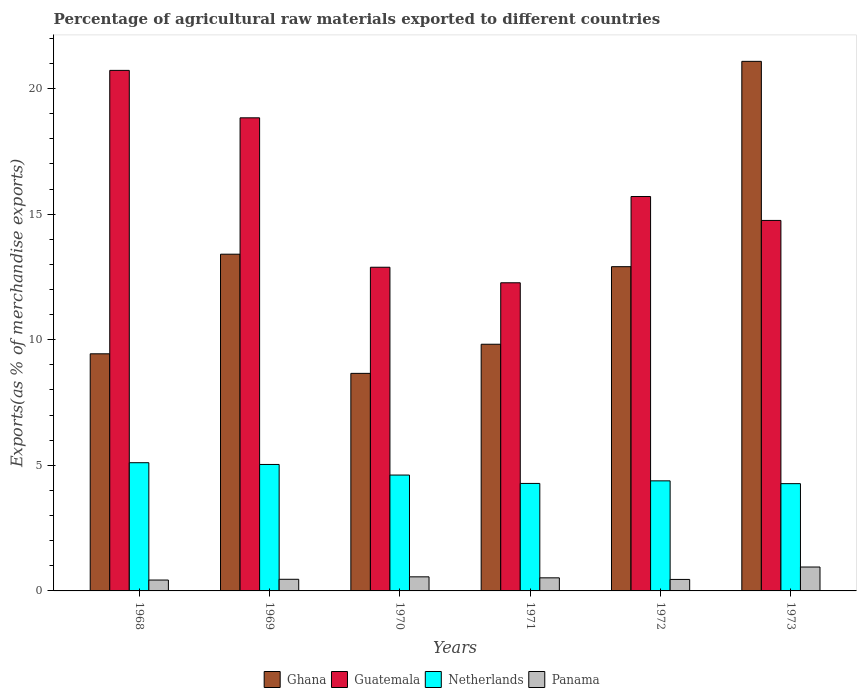How many different coloured bars are there?
Ensure brevity in your answer.  4. How many groups of bars are there?
Your answer should be compact. 6. Are the number of bars per tick equal to the number of legend labels?
Your answer should be very brief. Yes. Are the number of bars on each tick of the X-axis equal?
Provide a short and direct response. Yes. How many bars are there on the 2nd tick from the right?
Provide a succinct answer. 4. What is the label of the 5th group of bars from the left?
Ensure brevity in your answer.  1972. What is the percentage of exports to different countries in Guatemala in 1972?
Offer a very short reply. 15.7. Across all years, what is the maximum percentage of exports to different countries in Netherlands?
Your answer should be very brief. 5.1. Across all years, what is the minimum percentage of exports to different countries in Ghana?
Keep it short and to the point. 8.66. In which year was the percentage of exports to different countries in Guatemala maximum?
Offer a terse response. 1968. What is the total percentage of exports to different countries in Netherlands in the graph?
Offer a very short reply. 27.68. What is the difference between the percentage of exports to different countries in Panama in 1970 and that in 1973?
Ensure brevity in your answer.  -0.39. What is the difference between the percentage of exports to different countries in Panama in 1973 and the percentage of exports to different countries in Netherlands in 1971?
Give a very brief answer. -3.33. What is the average percentage of exports to different countries in Panama per year?
Your answer should be compact. 0.56. In the year 1973, what is the difference between the percentage of exports to different countries in Netherlands and percentage of exports to different countries in Guatemala?
Offer a very short reply. -10.48. In how many years, is the percentage of exports to different countries in Ghana greater than 3 %?
Give a very brief answer. 6. What is the ratio of the percentage of exports to different countries in Ghana in 1970 to that in 1971?
Keep it short and to the point. 0.88. Is the difference between the percentage of exports to different countries in Netherlands in 1968 and 1972 greater than the difference between the percentage of exports to different countries in Guatemala in 1968 and 1972?
Give a very brief answer. No. What is the difference between the highest and the second highest percentage of exports to different countries in Netherlands?
Keep it short and to the point. 0.07. What is the difference between the highest and the lowest percentage of exports to different countries in Panama?
Provide a short and direct response. 0.52. In how many years, is the percentage of exports to different countries in Netherlands greater than the average percentage of exports to different countries in Netherlands taken over all years?
Ensure brevity in your answer.  2. Is it the case that in every year, the sum of the percentage of exports to different countries in Panama and percentage of exports to different countries in Guatemala is greater than the sum of percentage of exports to different countries in Netherlands and percentage of exports to different countries in Ghana?
Offer a terse response. No. What does the 2nd bar from the left in 1971 represents?
Offer a very short reply. Guatemala. What does the 4th bar from the right in 1969 represents?
Offer a terse response. Ghana. How many bars are there?
Provide a short and direct response. 24. Are the values on the major ticks of Y-axis written in scientific E-notation?
Give a very brief answer. No. Does the graph contain any zero values?
Your response must be concise. No. Does the graph contain grids?
Ensure brevity in your answer.  No. Where does the legend appear in the graph?
Provide a short and direct response. Bottom center. How many legend labels are there?
Your response must be concise. 4. How are the legend labels stacked?
Offer a very short reply. Horizontal. What is the title of the graph?
Keep it short and to the point. Percentage of agricultural raw materials exported to different countries. What is the label or title of the Y-axis?
Offer a very short reply. Exports(as % of merchandise exports). What is the Exports(as % of merchandise exports) of Ghana in 1968?
Keep it short and to the point. 9.44. What is the Exports(as % of merchandise exports) in Guatemala in 1968?
Give a very brief answer. 20.72. What is the Exports(as % of merchandise exports) of Netherlands in 1968?
Provide a short and direct response. 5.1. What is the Exports(as % of merchandise exports) of Panama in 1968?
Make the answer very short. 0.43. What is the Exports(as % of merchandise exports) in Ghana in 1969?
Offer a terse response. 13.41. What is the Exports(as % of merchandise exports) in Guatemala in 1969?
Make the answer very short. 18.83. What is the Exports(as % of merchandise exports) of Netherlands in 1969?
Provide a short and direct response. 5.03. What is the Exports(as % of merchandise exports) of Panama in 1969?
Keep it short and to the point. 0.46. What is the Exports(as % of merchandise exports) in Ghana in 1970?
Offer a very short reply. 8.66. What is the Exports(as % of merchandise exports) of Guatemala in 1970?
Offer a terse response. 12.89. What is the Exports(as % of merchandise exports) of Netherlands in 1970?
Make the answer very short. 4.61. What is the Exports(as % of merchandise exports) in Panama in 1970?
Your response must be concise. 0.56. What is the Exports(as % of merchandise exports) of Ghana in 1971?
Your answer should be compact. 9.82. What is the Exports(as % of merchandise exports) of Guatemala in 1971?
Your answer should be compact. 12.27. What is the Exports(as % of merchandise exports) in Netherlands in 1971?
Your answer should be very brief. 4.28. What is the Exports(as % of merchandise exports) of Panama in 1971?
Your answer should be compact. 0.52. What is the Exports(as % of merchandise exports) in Ghana in 1972?
Ensure brevity in your answer.  12.91. What is the Exports(as % of merchandise exports) in Guatemala in 1972?
Your answer should be very brief. 15.7. What is the Exports(as % of merchandise exports) of Netherlands in 1972?
Give a very brief answer. 4.38. What is the Exports(as % of merchandise exports) of Panama in 1972?
Offer a very short reply. 0.46. What is the Exports(as % of merchandise exports) of Ghana in 1973?
Your answer should be very brief. 21.08. What is the Exports(as % of merchandise exports) in Guatemala in 1973?
Offer a terse response. 14.75. What is the Exports(as % of merchandise exports) of Netherlands in 1973?
Offer a very short reply. 4.27. What is the Exports(as % of merchandise exports) in Panama in 1973?
Your answer should be very brief. 0.95. Across all years, what is the maximum Exports(as % of merchandise exports) in Ghana?
Offer a terse response. 21.08. Across all years, what is the maximum Exports(as % of merchandise exports) in Guatemala?
Ensure brevity in your answer.  20.72. Across all years, what is the maximum Exports(as % of merchandise exports) of Netherlands?
Your answer should be very brief. 5.1. Across all years, what is the maximum Exports(as % of merchandise exports) of Panama?
Give a very brief answer. 0.95. Across all years, what is the minimum Exports(as % of merchandise exports) of Ghana?
Your answer should be very brief. 8.66. Across all years, what is the minimum Exports(as % of merchandise exports) in Guatemala?
Provide a short and direct response. 12.27. Across all years, what is the minimum Exports(as % of merchandise exports) of Netherlands?
Give a very brief answer. 4.27. Across all years, what is the minimum Exports(as % of merchandise exports) in Panama?
Your response must be concise. 0.43. What is the total Exports(as % of merchandise exports) in Ghana in the graph?
Make the answer very short. 75.32. What is the total Exports(as % of merchandise exports) in Guatemala in the graph?
Offer a very short reply. 95.16. What is the total Exports(as % of merchandise exports) in Netherlands in the graph?
Give a very brief answer. 27.68. What is the total Exports(as % of merchandise exports) of Panama in the graph?
Provide a short and direct response. 3.39. What is the difference between the Exports(as % of merchandise exports) of Ghana in 1968 and that in 1969?
Offer a terse response. -3.97. What is the difference between the Exports(as % of merchandise exports) in Guatemala in 1968 and that in 1969?
Keep it short and to the point. 1.89. What is the difference between the Exports(as % of merchandise exports) in Netherlands in 1968 and that in 1969?
Your answer should be very brief. 0.07. What is the difference between the Exports(as % of merchandise exports) of Panama in 1968 and that in 1969?
Offer a terse response. -0.03. What is the difference between the Exports(as % of merchandise exports) of Ghana in 1968 and that in 1970?
Offer a terse response. 0.78. What is the difference between the Exports(as % of merchandise exports) of Guatemala in 1968 and that in 1970?
Offer a very short reply. 7.84. What is the difference between the Exports(as % of merchandise exports) of Netherlands in 1968 and that in 1970?
Your answer should be very brief. 0.49. What is the difference between the Exports(as % of merchandise exports) of Panama in 1968 and that in 1970?
Make the answer very short. -0.13. What is the difference between the Exports(as % of merchandise exports) of Ghana in 1968 and that in 1971?
Offer a very short reply. -0.38. What is the difference between the Exports(as % of merchandise exports) in Guatemala in 1968 and that in 1971?
Give a very brief answer. 8.46. What is the difference between the Exports(as % of merchandise exports) in Netherlands in 1968 and that in 1971?
Ensure brevity in your answer.  0.82. What is the difference between the Exports(as % of merchandise exports) in Panama in 1968 and that in 1971?
Make the answer very short. -0.09. What is the difference between the Exports(as % of merchandise exports) of Ghana in 1968 and that in 1972?
Your response must be concise. -3.47. What is the difference between the Exports(as % of merchandise exports) in Guatemala in 1968 and that in 1972?
Provide a short and direct response. 5.02. What is the difference between the Exports(as % of merchandise exports) of Netherlands in 1968 and that in 1972?
Your answer should be very brief. 0.72. What is the difference between the Exports(as % of merchandise exports) of Panama in 1968 and that in 1972?
Offer a terse response. -0.02. What is the difference between the Exports(as % of merchandise exports) of Ghana in 1968 and that in 1973?
Your response must be concise. -11.64. What is the difference between the Exports(as % of merchandise exports) in Guatemala in 1968 and that in 1973?
Make the answer very short. 5.97. What is the difference between the Exports(as % of merchandise exports) of Netherlands in 1968 and that in 1973?
Offer a very short reply. 0.83. What is the difference between the Exports(as % of merchandise exports) in Panama in 1968 and that in 1973?
Provide a succinct answer. -0.52. What is the difference between the Exports(as % of merchandise exports) in Ghana in 1969 and that in 1970?
Your answer should be compact. 4.74. What is the difference between the Exports(as % of merchandise exports) in Guatemala in 1969 and that in 1970?
Make the answer very short. 5.95. What is the difference between the Exports(as % of merchandise exports) in Netherlands in 1969 and that in 1970?
Your answer should be very brief. 0.42. What is the difference between the Exports(as % of merchandise exports) of Panama in 1969 and that in 1970?
Your answer should be very brief. -0.1. What is the difference between the Exports(as % of merchandise exports) of Ghana in 1969 and that in 1971?
Provide a succinct answer. 3.58. What is the difference between the Exports(as % of merchandise exports) in Guatemala in 1969 and that in 1971?
Your answer should be compact. 6.57. What is the difference between the Exports(as % of merchandise exports) in Netherlands in 1969 and that in 1971?
Offer a very short reply. 0.76. What is the difference between the Exports(as % of merchandise exports) of Panama in 1969 and that in 1971?
Your answer should be very brief. -0.06. What is the difference between the Exports(as % of merchandise exports) in Ghana in 1969 and that in 1972?
Offer a very short reply. 0.5. What is the difference between the Exports(as % of merchandise exports) in Guatemala in 1969 and that in 1972?
Offer a very short reply. 3.13. What is the difference between the Exports(as % of merchandise exports) of Netherlands in 1969 and that in 1972?
Provide a succinct answer. 0.65. What is the difference between the Exports(as % of merchandise exports) in Panama in 1969 and that in 1972?
Give a very brief answer. 0.01. What is the difference between the Exports(as % of merchandise exports) in Ghana in 1969 and that in 1973?
Offer a terse response. -7.68. What is the difference between the Exports(as % of merchandise exports) in Guatemala in 1969 and that in 1973?
Give a very brief answer. 4.08. What is the difference between the Exports(as % of merchandise exports) in Netherlands in 1969 and that in 1973?
Offer a terse response. 0.76. What is the difference between the Exports(as % of merchandise exports) in Panama in 1969 and that in 1973?
Your response must be concise. -0.49. What is the difference between the Exports(as % of merchandise exports) of Ghana in 1970 and that in 1971?
Your answer should be very brief. -1.16. What is the difference between the Exports(as % of merchandise exports) of Guatemala in 1970 and that in 1971?
Provide a succinct answer. 0.62. What is the difference between the Exports(as % of merchandise exports) in Netherlands in 1970 and that in 1971?
Ensure brevity in your answer.  0.33. What is the difference between the Exports(as % of merchandise exports) of Panama in 1970 and that in 1971?
Your answer should be very brief. 0.04. What is the difference between the Exports(as % of merchandise exports) in Ghana in 1970 and that in 1972?
Your answer should be compact. -4.25. What is the difference between the Exports(as % of merchandise exports) of Guatemala in 1970 and that in 1972?
Offer a terse response. -2.82. What is the difference between the Exports(as % of merchandise exports) of Netherlands in 1970 and that in 1972?
Offer a terse response. 0.23. What is the difference between the Exports(as % of merchandise exports) of Panama in 1970 and that in 1972?
Provide a short and direct response. 0.1. What is the difference between the Exports(as % of merchandise exports) in Ghana in 1970 and that in 1973?
Your answer should be compact. -12.42. What is the difference between the Exports(as % of merchandise exports) in Guatemala in 1970 and that in 1973?
Ensure brevity in your answer.  -1.86. What is the difference between the Exports(as % of merchandise exports) in Netherlands in 1970 and that in 1973?
Make the answer very short. 0.34. What is the difference between the Exports(as % of merchandise exports) in Panama in 1970 and that in 1973?
Offer a very short reply. -0.39. What is the difference between the Exports(as % of merchandise exports) in Ghana in 1971 and that in 1972?
Provide a succinct answer. -3.09. What is the difference between the Exports(as % of merchandise exports) in Guatemala in 1971 and that in 1972?
Keep it short and to the point. -3.43. What is the difference between the Exports(as % of merchandise exports) of Netherlands in 1971 and that in 1972?
Offer a terse response. -0.1. What is the difference between the Exports(as % of merchandise exports) of Panama in 1971 and that in 1972?
Your answer should be very brief. 0.06. What is the difference between the Exports(as % of merchandise exports) in Ghana in 1971 and that in 1973?
Your answer should be very brief. -11.26. What is the difference between the Exports(as % of merchandise exports) in Guatemala in 1971 and that in 1973?
Your answer should be compact. -2.48. What is the difference between the Exports(as % of merchandise exports) of Netherlands in 1971 and that in 1973?
Your answer should be very brief. 0.01. What is the difference between the Exports(as % of merchandise exports) in Panama in 1971 and that in 1973?
Offer a very short reply. -0.43. What is the difference between the Exports(as % of merchandise exports) of Ghana in 1972 and that in 1973?
Offer a terse response. -8.17. What is the difference between the Exports(as % of merchandise exports) of Guatemala in 1972 and that in 1973?
Your answer should be compact. 0.95. What is the difference between the Exports(as % of merchandise exports) of Netherlands in 1972 and that in 1973?
Keep it short and to the point. 0.11. What is the difference between the Exports(as % of merchandise exports) of Panama in 1972 and that in 1973?
Your response must be concise. -0.49. What is the difference between the Exports(as % of merchandise exports) in Ghana in 1968 and the Exports(as % of merchandise exports) in Guatemala in 1969?
Give a very brief answer. -9.39. What is the difference between the Exports(as % of merchandise exports) of Ghana in 1968 and the Exports(as % of merchandise exports) of Netherlands in 1969?
Keep it short and to the point. 4.41. What is the difference between the Exports(as % of merchandise exports) in Ghana in 1968 and the Exports(as % of merchandise exports) in Panama in 1969?
Offer a terse response. 8.98. What is the difference between the Exports(as % of merchandise exports) of Guatemala in 1968 and the Exports(as % of merchandise exports) of Netherlands in 1969?
Provide a short and direct response. 15.69. What is the difference between the Exports(as % of merchandise exports) of Guatemala in 1968 and the Exports(as % of merchandise exports) of Panama in 1969?
Your answer should be very brief. 20.26. What is the difference between the Exports(as % of merchandise exports) of Netherlands in 1968 and the Exports(as % of merchandise exports) of Panama in 1969?
Give a very brief answer. 4.64. What is the difference between the Exports(as % of merchandise exports) of Ghana in 1968 and the Exports(as % of merchandise exports) of Guatemala in 1970?
Make the answer very short. -3.45. What is the difference between the Exports(as % of merchandise exports) in Ghana in 1968 and the Exports(as % of merchandise exports) in Netherlands in 1970?
Give a very brief answer. 4.83. What is the difference between the Exports(as % of merchandise exports) in Ghana in 1968 and the Exports(as % of merchandise exports) in Panama in 1970?
Provide a short and direct response. 8.88. What is the difference between the Exports(as % of merchandise exports) in Guatemala in 1968 and the Exports(as % of merchandise exports) in Netherlands in 1970?
Offer a terse response. 16.11. What is the difference between the Exports(as % of merchandise exports) of Guatemala in 1968 and the Exports(as % of merchandise exports) of Panama in 1970?
Make the answer very short. 20.16. What is the difference between the Exports(as % of merchandise exports) of Netherlands in 1968 and the Exports(as % of merchandise exports) of Panama in 1970?
Your answer should be very brief. 4.54. What is the difference between the Exports(as % of merchandise exports) of Ghana in 1968 and the Exports(as % of merchandise exports) of Guatemala in 1971?
Make the answer very short. -2.83. What is the difference between the Exports(as % of merchandise exports) of Ghana in 1968 and the Exports(as % of merchandise exports) of Netherlands in 1971?
Provide a succinct answer. 5.16. What is the difference between the Exports(as % of merchandise exports) in Ghana in 1968 and the Exports(as % of merchandise exports) in Panama in 1971?
Make the answer very short. 8.92. What is the difference between the Exports(as % of merchandise exports) in Guatemala in 1968 and the Exports(as % of merchandise exports) in Netherlands in 1971?
Provide a succinct answer. 16.44. What is the difference between the Exports(as % of merchandise exports) in Guatemala in 1968 and the Exports(as % of merchandise exports) in Panama in 1971?
Give a very brief answer. 20.2. What is the difference between the Exports(as % of merchandise exports) of Netherlands in 1968 and the Exports(as % of merchandise exports) of Panama in 1971?
Ensure brevity in your answer.  4.58. What is the difference between the Exports(as % of merchandise exports) in Ghana in 1968 and the Exports(as % of merchandise exports) in Guatemala in 1972?
Ensure brevity in your answer.  -6.26. What is the difference between the Exports(as % of merchandise exports) in Ghana in 1968 and the Exports(as % of merchandise exports) in Netherlands in 1972?
Make the answer very short. 5.06. What is the difference between the Exports(as % of merchandise exports) in Ghana in 1968 and the Exports(as % of merchandise exports) in Panama in 1972?
Provide a succinct answer. 8.98. What is the difference between the Exports(as % of merchandise exports) of Guatemala in 1968 and the Exports(as % of merchandise exports) of Netherlands in 1972?
Provide a short and direct response. 16.34. What is the difference between the Exports(as % of merchandise exports) in Guatemala in 1968 and the Exports(as % of merchandise exports) in Panama in 1972?
Give a very brief answer. 20.27. What is the difference between the Exports(as % of merchandise exports) in Netherlands in 1968 and the Exports(as % of merchandise exports) in Panama in 1972?
Ensure brevity in your answer.  4.65. What is the difference between the Exports(as % of merchandise exports) in Ghana in 1968 and the Exports(as % of merchandise exports) in Guatemala in 1973?
Ensure brevity in your answer.  -5.31. What is the difference between the Exports(as % of merchandise exports) of Ghana in 1968 and the Exports(as % of merchandise exports) of Netherlands in 1973?
Your answer should be very brief. 5.17. What is the difference between the Exports(as % of merchandise exports) of Ghana in 1968 and the Exports(as % of merchandise exports) of Panama in 1973?
Provide a short and direct response. 8.49. What is the difference between the Exports(as % of merchandise exports) in Guatemala in 1968 and the Exports(as % of merchandise exports) in Netherlands in 1973?
Provide a short and direct response. 16.45. What is the difference between the Exports(as % of merchandise exports) in Guatemala in 1968 and the Exports(as % of merchandise exports) in Panama in 1973?
Provide a short and direct response. 19.77. What is the difference between the Exports(as % of merchandise exports) in Netherlands in 1968 and the Exports(as % of merchandise exports) in Panama in 1973?
Your answer should be very brief. 4.15. What is the difference between the Exports(as % of merchandise exports) in Ghana in 1969 and the Exports(as % of merchandise exports) in Guatemala in 1970?
Your response must be concise. 0.52. What is the difference between the Exports(as % of merchandise exports) in Ghana in 1969 and the Exports(as % of merchandise exports) in Netherlands in 1970?
Your answer should be very brief. 8.79. What is the difference between the Exports(as % of merchandise exports) of Ghana in 1969 and the Exports(as % of merchandise exports) of Panama in 1970?
Ensure brevity in your answer.  12.84. What is the difference between the Exports(as % of merchandise exports) in Guatemala in 1969 and the Exports(as % of merchandise exports) in Netherlands in 1970?
Provide a succinct answer. 14.22. What is the difference between the Exports(as % of merchandise exports) of Guatemala in 1969 and the Exports(as % of merchandise exports) of Panama in 1970?
Make the answer very short. 18.27. What is the difference between the Exports(as % of merchandise exports) of Netherlands in 1969 and the Exports(as % of merchandise exports) of Panama in 1970?
Your response must be concise. 4.47. What is the difference between the Exports(as % of merchandise exports) in Ghana in 1969 and the Exports(as % of merchandise exports) in Guatemala in 1971?
Your answer should be compact. 1.14. What is the difference between the Exports(as % of merchandise exports) in Ghana in 1969 and the Exports(as % of merchandise exports) in Netherlands in 1971?
Offer a terse response. 9.13. What is the difference between the Exports(as % of merchandise exports) in Ghana in 1969 and the Exports(as % of merchandise exports) in Panama in 1971?
Provide a succinct answer. 12.88. What is the difference between the Exports(as % of merchandise exports) in Guatemala in 1969 and the Exports(as % of merchandise exports) in Netherlands in 1971?
Make the answer very short. 14.56. What is the difference between the Exports(as % of merchandise exports) in Guatemala in 1969 and the Exports(as % of merchandise exports) in Panama in 1971?
Offer a terse response. 18.31. What is the difference between the Exports(as % of merchandise exports) in Netherlands in 1969 and the Exports(as % of merchandise exports) in Panama in 1971?
Keep it short and to the point. 4.51. What is the difference between the Exports(as % of merchandise exports) in Ghana in 1969 and the Exports(as % of merchandise exports) in Guatemala in 1972?
Ensure brevity in your answer.  -2.3. What is the difference between the Exports(as % of merchandise exports) of Ghana in 1969 and the Exports(as % of merchandise exports) of Netherlands in 1972?
Keep it short and to the point. 9.02. What is the difference between the Exports(as % of merchandise exports) in Ghana in 1969 and the Exports(as % of merchandise exports) in Panama in 1972?
Make the answer very short. 12.95. What is the difference between the Exports(as % of merchandise exports) of Guatemala in 1969 and the Exports(as % of merchandise exports) of Netherlands in 1972?
Provide a short and direct response. 14.45. What is the difference between the Exports(as % of merchandise exports) of Guatemala in 1969 and the Exports(as % of merchandise exports) of Panama in 1972?
Provide a short and direct response. 18.38. What is the difference between the Exports(as % of merchandise exports) in Netherlands in 1969 and the Exports(as % of merchandise exports) in Panama in 1972?
Provide a succinct answer. 4.58. What is the difference between the Exports(as % of merchandise exports) in Ghana in 1969 and the Exports(as % of merchandise exports) in Guatemala in 1973?
Give a very brief answer. -1.34. What is the difference between the Exports(as % of merchandise exports) of Ghana in 1969 and the Exports(as % of merchandise exports) of Netherlands in 1973?
Provide a succinct answer. 9.13. What is the difference between the Exports(as % of merchandise exports) of Ghana in 1969 and the Exports(as % of merchandise exports) of Panama in 1973?
Ensure brevity in your answer.  12.45. What is the difference between the Exports(as % of merchandise exports) of Guatemala in 1969 and the Exports(as % of merchandise exports) of Netherlands in 1973?
Provide a short and direct response. 14.56. What is the difference between the Exports(as % of merchandise exports) in Guatemala in 1969 and the Exports(as % of merchandise exports) in Panama in 1973?
Give a very brief answer. 17.88. What is the difference between the Exports(as % of merchandise exports) of Netherlands in 1969 and the Exports(as % of merchandise exports) of Panama in 1973?
Your answer should be very brief. 4.08. What is the difference between the Exports(as % of merchandise exports) of Ghana in 1970 and the Exports(as % of merchandise exports) of Guatemala in 1971?
Your answer should be compact. -3.61. What is the difference between the Exports(as % of merchandise exports) in Ghana in 1970 and the Exports(as % of merchandise exports) in Netherlands in 1971?
Keep it short and to the point. 4.38. What is the difference between the Exports(as % of merchandise exports) of Ghana in 1970 and the Exports(as % of merchandise exports) of Panama in 1971?
Your answer should be very brief. 8.14. What is the difference between the Exports(as % of merchandise exports) in Guatemala in 1970 and the Exports(as % of merchandise exports) in Netherlands in 1971?
Provide a succinct answer. 8.61. What is the difference between the Exports(as % of merchandise exports) in Guatemala in 1970 and the Exports(as % of merchandise exports) in Panama in 1971?
Your answer should be compact. 12.37. What is the difference between the Exports(as % of merchandise exports) in Netherlands in 1970 and the Exports(as % of merchandise exports) in Panama in 1971?
Make the answer very short. 4.09. What is the difference between the Exports(as % of merchandise exports) in Ghana in 1970 and the Exports(as % of merchandise exports) in Guatemala in 1972?
Provide a short and direct response. -7.04. What is the difference between the Exports(as % of merchandise exports) in Ghana in 1970 and the Exports(as % of merchandise exports) in Netherlands in 1972?
Provide a short and direct response. 4.28. What is the difference between the Exports(as % of merchandise exports) in Ghana in 1970 and the Exports(as % of merchandise exports) in Panama in 1972?
Your answer should be compact. 8.2. What is the difference between the Exports(as % of merchandise exports) in Guatemala in 1970 and the Exports(as % of merchandise exports) in Netherlands in 1972?
Give a very brief answer. 8.5. What is the difference between the Exports(as % of merchandise exports) in Guatemala in 1970 and the Exports(as % of merchandise exports) in Panama in 1972?
Provide a short and direct response. 12.43. What is the difference between the Exports(as % of merchandise exports) of Netherlands in 1970 and the Exports(as % of merchandise exports) of Panama in 1972?
Provide a short and direct response. 4.16. What is the difference between the Exports(as % of merchandise exports) in Ghana in 1970 and the Exports(as % of merchandise exports) in Guatemala in 1973?
Provide a succinct answer. -6.09. What is the difference between the Exports(as % of merchandise exports) in Ghana in 1970 and the Exports(as % of merchandise exports) in Netherlands in 1973?
Keep it short and to the point. 4.39. What is the difference between the Exports(as % of merchandise exports) of Ghana in 1970 and the Exports(as % of merchandise exports) of Panama in 1973?
Give a very brief answer. 7.71. What is the difference between the Exports(as % of merchandise exports) of Guatemala in 1970 and the Exports(as % of merchandise exports) of Netherlands in 1973?
Provide a succinct answer. 8.62. What is the difference between the Exports(as % of merchandise exports) in Guatemala in 1970 and the Exports(as % of merchandise exports) in Panama in 1973?
Offer a very short reply. 11.94. What is the difference between the Exports(as % of merchandise exports) in Netherlands in 1970 and the Exports(as % of merchandise exports) in Panama in 1973?
Make the answer very short. 3.66. What is the difference between the Exports(as % of merchandise exports) in Ghana in 1971 and the Exports(as % of merchandise exports) in Guatemala in 1972?
Provide a succinct answer. -5.88. What is the difference between the Exports(as % of merchandise exports) in Ghana in 1971 and the Exports(as % of merchandise exports) in Netherlands in 1972?
Offer a terse response. 5.44. What is the difference between the Exports(as % of merchandise exports) of Ghana in 1971 and the Exports(as % of merchandise exports) of Panama in 1972?
Your answer should be very brief. 9.36. What is the difference between the Exports(as % of merchandise exports) of Guatemala in 1971 and the Exports(as % of merchandise exports) of Netherlands in 1972?
Your answer should be very brief. 7.89. What is the difference between the Exports(as % of merchandise exports) in Guatemala in 1971 and the Exports(as % of merchandise exports) in Panama in 1972?
Your response must be concise. 11.81. What is the difference between the Exports(as % of merchandise exports) of Netherlands in 1971 and the Exports(as % of merchandise exports) of Panama in 1972?
Make the answer very short. 3.82. What is the difference between the Exports(as % of merchandise exports) of Ghana in 1971 and the Exports(as % of merchandise exports) of Guatemala in 1973?
Make the answer very short. -4.93. What is the difference between the Exports(as % of merchandise exports) in Ghana in 1971 and the Exports(as % of merchandise exports) in Netherlands in 1973?
Your answer should be very brief. 5.55. What is the difference between the Exports(as % of merchandise exports) in Ghana in 1971 and the Exports(as % of merchandise exports) in Panama in 1973?
Make the answer very short. 8.87. What is the difference between the Exports(as % of merchandise exports) of Guatemala in 1971 and the Exports(as % of merchandise exports) of Netherlands in 1973?
Make the answer very short. 8. What is the difference between the Exports(as % of merchandise exports) in Guatemala in 1971 and the Exports(as % of merchandise exports) in Panama in 1973?
Offer a very short reply. 11.32. What is the difference between the Exports(as % of merchandise exports) in Netherlands in 1971 and the Exports(as % of merchandise exports) in Panama in 1973?
Keep it short and to the point. 3.33. What is the difference between the Exports(as % of merchandise exports) of Ghana in 1972 and the Exports(as % of merchandise exports) of Guatemala in 1973?
Keep it short and to the point. -1.84. What is the difference between the Exports(as % of merchandise exports) of Ghana in 1972 and the Exports(as % of merchandise exports) of Netherlands in 1973?
Your answer should be compact. 8.64. What is the difference between the Exports(as % of merchandise exports) of Ghana in 1972 and the Exports(as % of merchandise exports) of Panama in 1973?
Make the answer very short. 11.96. What is the difference between the Exports(as % of merchandise exports) in Guatemala in 1972 and the Exports(as % of merchandise exports) in Netherlands in 1973?
Give a very brief answer. 11.43. What is the difference between the Exports(as % of merchandise exports) in Guatemala in 1972 and the Exports(as % of merchandise exports) in Panama in 1973?
Keep it short and to the point. 14.75. What is the difference between the Exports(as % of merchandise exports) of Netherlands in 1972 and the Exports(as % of merchandise exports) of Panama in 1973?
Offer a terse response. 3.43. What is the average Exports(as % of merchandise exports) of Ghana per year?
Provide a succinct answer. 12.55. What is the average Exports(as % of merchandise exports) of Guatemala per year?
Ensure brevity in your answer.  15.86. What is the average Exports(as % of merchandise exports) of Netherlands per year?
Provide a succinct answer. 4.61. What is the average Exports(as % of merchandise exports) of Panama per year?
Offer a very short reply. 0.56. In the year 1968, what is the difference between the Exports(as % of merchandise exports) of Ghana and Exports(as % of merchandise exports) of Guatemala?
Your answer should be compact. -11.28. In the year 1968, what is the difference between the Exports(as % of merchandise exports) in Ghana and Exports(as % of merchandise exports) in Netherlands?
Your response must be concise. 4.34. In the year 1968, what is the difference between the Exports(as % of merchandise exports) of Ghana and Exports(as % of merchandise exports) of Panama?
Ensure brevity in your answer.  9.01. In the year 1968, what is the difference between the Exports(as % of merchandise exports) in Guatemala and Exports(as % of merchandise exports) in Netherlands?
Ensure brevity in your answer.  15.62. In the year 1968, what is the difference between the Exports(as % of merchandise exports) in Guatemala and Exports(as % of merchandise exports) in Panama?
Your answer should be compact. 20.29. In the year 1968, what is the difference between the Exports(as % of merchandise exports) in Netherlands and Exports(as % of merchandise exports) in Panama?
Give a very brief answer. 4.67. In the year 1969, what is the difference between the Exports(as % of merchandise exports) in Ghana and Exports(as % of merchandise exports) in Guatemala?
Keep it short and to the point. -5.43. In the year 1969, what is the difference between the Exports(as % of merchandise exports) of Ghana and Exports(as % of merchandise exports) of Netherlands?
Provide a short and direct response. 8.37. In the year 1969, what is the difference between the Exports(as % of merchandise exports) of Ghana and Exports(as % of merchandise exports) of Panama?
Ensure brevity in your answer.  12.94. In the year 1969, what is the difference between the Exports(as % of merchandise exports) of Guatemala and Exports(as % of merchandise exports) of Panama?
Provide a succinct answer. 18.37. In the year 1969, what is the difference between the Exports(as % of merchandise exports) of Netherlands and Exports(as % of merchandise exports) of Panama?
Provide a short and direct response. 4.57. In the year 1970, what is the difference between the Exports(as % of merchandise exports) in Ghana and Exports(as % of merchandise exports) in Guatemala?
Ensure brevity in your answer.  -4.23. In the year 1970, what is the difference between the Exports(as % of merchandise exports) of Ghana and Exports(as % of merchandise exports) of Netherlands?
Keep it short and to the point. 4.05. In the year 1970, what is the difference between the Exports(as % of merchandise exports) in Ghana and Exports(as % of merchandise exports) in Panama?
Your response must be concise. 8.1. In the year 1970, what is the difference between the Exports(as % of merchandise exports) of Guatemala and Exports(as % of merchandise exports) of Netherlands?
Offer a very short reply. 8.27. In the year 1970, what is the difference between the Exports(as % of merchandise exports) in Guatemala and Exports(as % of merchandise exports) in Panama?
Offer a very short reply. 12.33. In the year 1970, what is the difference between the Exports(as % of merchandise exports) of Netherlands and Exports(as % of merchandise exports) of Panama?
Provide a succinct answer. 4.05. In the year 1971, what is the difference between the Exports(as % of merchandise exports) in Ghana and Exports(as % of merchandise exports) in Guatemala?
Provide a short and direct response. -2.45. In the year 1971, what is the difference between the Exports(as % of merchandise exports) in Ghana and Exports(as % of merchandise exports) in Netherlands?
Ensure brevity in your answer.  5.54. In the year 1971, what is the difference between the Exports(as % of merchandise exports) of Ghana and Exports(as % of merchandise exports) of Panama?
Ensure brevity in your answer.  9.3. In the year 1971, what is the difference between the Exports(as % of merchandise exports) in Guatemala and Exports(as % of merchandise exports) in Netherlands?
Offer a terse response. 7.99. In the year 1971, what is the difference between the Exports(as % of merchandise exports) of Guatemala and Exports(as % of merchandise exports) of Panama?
Ensure brevity in your answer.  11.75. In the year 1971, what is the difference between the Exports(as % of merchandise exports) of Netherlands and Exports(as % of merchandise exports) of Panama?
Offer a very short reply. 3.76. In the year 1972, what is the difference between the Exports(as % of merchandise exports) in Ghana and Exports(as % of merchandise exports) in Guatemala?
Ensure brevity in your answer.  -2.79. In the year 1972, what is the difference between the Exports(as % of merchandise exports) of Ghana and Exports(as % of merchandise exports) of Netherlands?
Keep it short and to the point. 8.53. In the year 1972, what is the difference between the Exports(as % of merchandise exports) in Ghana and Exports(as % of merchandise exports) in Panama?
Provide a short and direct response. 12.45. In the year 1972, what is the difference between the Exports(as % of merchandise exports) of Guatemala and Exports(as % of merchandise exports) of Netherlands?
Offer a very short reply. 11.32. In the year 1972, what is the difference between the Exports(as % of merchandise exports) of Guatemala and Exports(as % of merchandise exports) of Panama?
Offer a terse response. 15.24. In the year 1972, what is the difference between the Exports(as % of merchandise exports) in Netherlands and Exports(as % of merchandise exports) in Panama?
Provide a succinct answer. 3.92. In the year 1973, what is the difference between the Exports(as % of merchandise exports) in Ghana and Exports(as % of merchandise exports) in Guatemala?
Make the answer very short. 6.33. In the year 1973, what is the difference between the Exports(as % of merchandise exports) of Ghana and Exports(as % of merchandise exports) of Netherlands?
Ensure brevity in your answer.  16.81. In the year 1973, what is the difference between the Exports(as % of merchandise exports) in Ghana and Exports(as % of merchandise exports) in Panama?
Your answer should be compact. 20.13. In the year 1973, what is the difference between the Exports(as % of merchandise exports) in Guatemala and Exports(as % of merchandise exports) in Netherlands?
Offer a very short reply. 10.48. In the year 1973, what is the difference between the Exports(as % of merchandise exports) in Guatemala and Exports(as % of merchandise exports) in Panama?
Your answer should be very brief. 13.8. In the year 1973, what is the difference between the Exports(as % of merchandise exports) in Netherlands and Exports(as % of merchandise exports) in Panama?
Provide a succinct answer. 3.32. What is the ratio of the Exports(as % of merchandise exports) in Ghana in 1968 to that in 1969?
Offer a very short reply. 0.7. What is the ratio of the Exports(as % of merchandise exports) in Guatemala in 1968 to that in 1969?
Ensure brevity in your answer.  1.1. What is the ratio of the Exports(as % of merchandise exports) of Netherlands in 1968 to that in 1969?
Your answer should be compact. 1.01. What is the ratio of the Exports(as % of merchandise exports) in Panama in 1968 to that in 1969?
Provide a short and direct response. 0.94. What is the ratio of the Exports(as % of merchandise exports) of Ghana in 1968 to that in 1970?
Keep it short and to the point. 1.09. What is the ratio of the Exports(as % of merchandise exports) in Guatemala in 1968 to that in 1970?
Your answer should be compact. 1.61. What is the ratio of the Exports(as % of merchandise exports) of Netherlands in 1968 to that in 1970?
Offer a terse response. 1.11. What is the ratio of the Exports(as % of merchandise exports) in Panama in 1968 to that in 1970?
Offer a terse response. 0.77. What is the ratio of the Exports(as % of merchandise exports) in Ghana in 1968 to that in 1971?
Provide a succinct answer. 0.96. What is the ratio of the Exports(as % of merchandise exports) of Guatemala in 1968 to that in 1971?
Your answer should be very brief. 1.69. What is the ratio of the Exports(as % of merchandise exports) of Netherlands in 1968 to that in 1971?
Offer a very short reply. 1.19. What is the ratio of the Exports(as % of merchandise exports) of Panama in 1968 to that in 1971?
Your answer should be very brief. 0.83. What is the ratio of the Exports(as % of merchandise exports) of Ghana in 1968 to that in 1972?
Offer a terse response. 0.73. What is the ratio of the Exports(as % of merchandise exports) of Guatemala in 1968 to that in 1972?
Provide a short and direct response. 1.32. What is the ratio of the Exports(as % of merchandise exports) in Netherlands in 1968 to that in 1972?
Your answer should be very brief. 1.16. What is the ratio of the Exports(as % of merchandise exports) in Panama in 1968 to that in 1972?
Give a very brief answer. 0.95. What is the ratio of the Exports(as % of merchandise exports) in Ghana in 1968 to that in 1973?
Provide a short and direct response. 0.45. What is the ratio of the Exports(as % of merchandise exports) in Guatemala in 1968 to that in 1973?
Keep it short and to the point. 1.41. What is the ratio of the Exports(as % of merchandise exports) in Netherlands in 1968 to that in 1973?
Your answer should be very brief. 1.2. What is the ratio of the Exports(as % of merchandise exports) of Panama in 1968 to that in 1973?
Offer a terse response. 0.46. What is the ratio of the Exports(as % of merchandise exports) in Ghana in 1969 to that in 1970?
Make the answer very short. 1.55. What is the ratio of the Exports(as % of merchandise exports) in Guatemala in 1969 to that in 1970?
Offer a very short reply. 1.46. What is the ratio of the Exports(as % of merchandise exports) of Netherlands in 1969 to that in 1970?
Provide a succinct answer. 1.09. What is the ratio of the Exports(as % of merchandise exports) of Panama in 1969 to that in 1970?
Your response must be concise. 0.83. What is the ratio of the Exports(as % of merchandise exports) of Ghana in 1969 to that in 1971?
Provide a succinct answer. 1.36. What is the ratio of the Exports(as % of merchandise exports) in Guatemala in 1969 to that in 1971?
Provide a succinct answer. 1.54. What is the ratio of the Exports(as % of merchandise exports) in Netherlands in 1969 to that in 1971?
Give a very brief answer. 1.18. What is the ratio of the Exports(as % of merchandise exports) of Panama in 1969 to that in 1971?
Keep it short and to the point. 0.89. What is the ratio of the Exports(as % of merchandise exports) of Ghana in 1969 to that in 1972?
Your response must be concise. 1.04. What is the ratio of the Exports(as % of merchandise exports) of Guatemala in 1969 to that in 1972?
Make the answer very short. 1.2. What is the ratio of the Exports(as % of merchandise exports) in Netherlands in 1969 to that in 1972?
Your answer should be very brief. 1.15. What is the ratio of the Exports(as % of merchandise exports) in Ghana in 1969 to that in 1973?
Your answer should be compact. 0.64. What is the ratio of the Exports(as % of merchandise exports) in Guatemala in 1969 to that in 1973?
Offer a terse response. 1.28. What is the ratio of the Exports(as % of merchandise exports) in Netherlands in 1969 to that in 1973?
Offer a terse response. 1.18. What is the ratio of the Exports(as % of merchandise exports) in Panama in 1969 to that in 1973?
Give a very brief answer. 0.49. What is the ratio of the Exports(as % of merchandise exports) in Ghana in 1970 to that in 1971?
Provide a succinct answer. 0.88. What is the ratio of the Exports(as % of merchandise exports) in Guatemala in 1970 to that in 1971?
Give a very brief answer. 1.05. What is the ratio of the Exports(as % of merchandise exports) in Netherlands in 1970 to that in 1971?
Give a very brief answer. 1.08. What is the ratio of the Exports(as % of merchandise exports) of Panama in 1970 to that in 1971?
Offer a terse response. 1.08. What is the ratio of the Exports(as % of merchandise exports) in Ghana in 1970 to that in 1972?
Give a very brief answer. 0.67. What is the ratio of the Exports(as % of merchandise exports) of Guatemala in 1970 to that in 1972?
Make the answer very short. 0.82. What is the ratio of the Exports(as % of merchandise exports) of Netherlands in 1970 to that in 1972?
Offer a very short reply. 1.05. What is the ratio of the Exports(as % of merchandise exports) of Panama in 1970 to that in 1972?
Provide a short and direct response. 1.22. What is the ratio of the Exports(as % of merchandise exports) in Ghana in 1970 to that in 1973?
Make the answer very short. 0.41. What is the ratio of the Exports(as % of merchandise exports) in Guatemala in 1970 to that in 1973?
Your response must be concise. 0.87. What is the ratio of the Exports(as % of merchandise exports) in Netherlands in 1970 to that in 1973?
Your response must be concise. 1.08. What is the ratio of the Exports(as % of merchandise exports) in Panama in 1970 to that in 1973?
Offer a very short reply. 0.59. What is the ratio of the Exports(as % of merchandise exports) of Ghana in 1971 to that in 1972?
Make the answer very short. 0.76. What is the ratio of the Exports(as % of merchandise exports) of Guatemala in 1971 to that in 1972?
Offer a very short reply. 0.78. What is the ratio of the Exports(as % of merchandise exports) in Netherlands in 1971 to that in 1972?
Your answer should be compact. 0.98. What is the ratio of the Exports(as % of merchandise exports) of Panama in 1971 to that in 1972?
Your response must be concise. 1.14. What is the ratio of the Exports(as % of merchandise exports) in Ghana in 1971 to that in 1973?
Your answer should be very brief. 0.47. What is the ratio of the Exports(as % of merchandise exports) in Guatemala in 1971 to that in 1973?
Offer a terse response. 0.83. What is the ratio of the Exports(as % of merchandise exports) in Panama in 1971 to that in 1973?
Provide a short and direct response. 0.55. What is the ratio of the Exports(as % of merchandise exports) of Ghana in 1972 to that in 1973?
Your answer should be compact. 0.61. What is the ratio of the Exports(as % of merchandise exports) in Guatemala in 1972 to that in 1973?
Offer a terse response. 1.06. What is the ratio of the Exports(as % of merchandise exports) in Netherlands in 1972 to that in 1973?
Your response must be concise. 1.03. What is the ratio of the Exports(as % of merchandise exports) in Panama in 1972 to that in 1973?
Give a very brief answer. 0.48. What is the difference between the highest and the second highest Exports(as % of merchandise exports) in Ghana?
Provide a short and direct response. 7.68. What is the difference between the highest and the second highest Exports(as % of merchandise exports) of Guatemala?
Keep it short and to the point. 1.89. What is the difference between the highest and the second highest Exports(as % of merchandise exports) in Netherlands?
Give a very brief answer. 0.07. What is the difference between the highest and the second highest Exports(as % of merchandise exports) of Panama?
Give a very brief answer. 0.39. What is the difference between the highest and the lowest Exports(as % of merchandise exports) of Ghana?
Your response must be concise. 12.42. What is the difference between the highest and the lowest Exports(as % of merchandise exports) in Guatemala?
Offer a terse response. 8.46. What is the difference between the highest and the lowest Exports(as % of merchandise exports) in Netherlands?
Offer a terse response. 0.83. What is the difference between the highest and the lowest Exports(as % of merchandise exports) in Panama?
Provide a succinct answer. 0.52. 